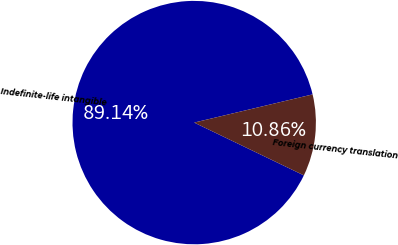Convert chart to OTSL. <chart><loc_0><loc_0><loc_500><loc_500><pie_chart><fcel>Indefinite-life intangible<fcel>Foreign currency translation<nl><fcel>89.14%<fcel>10.86%<nl></chart> 